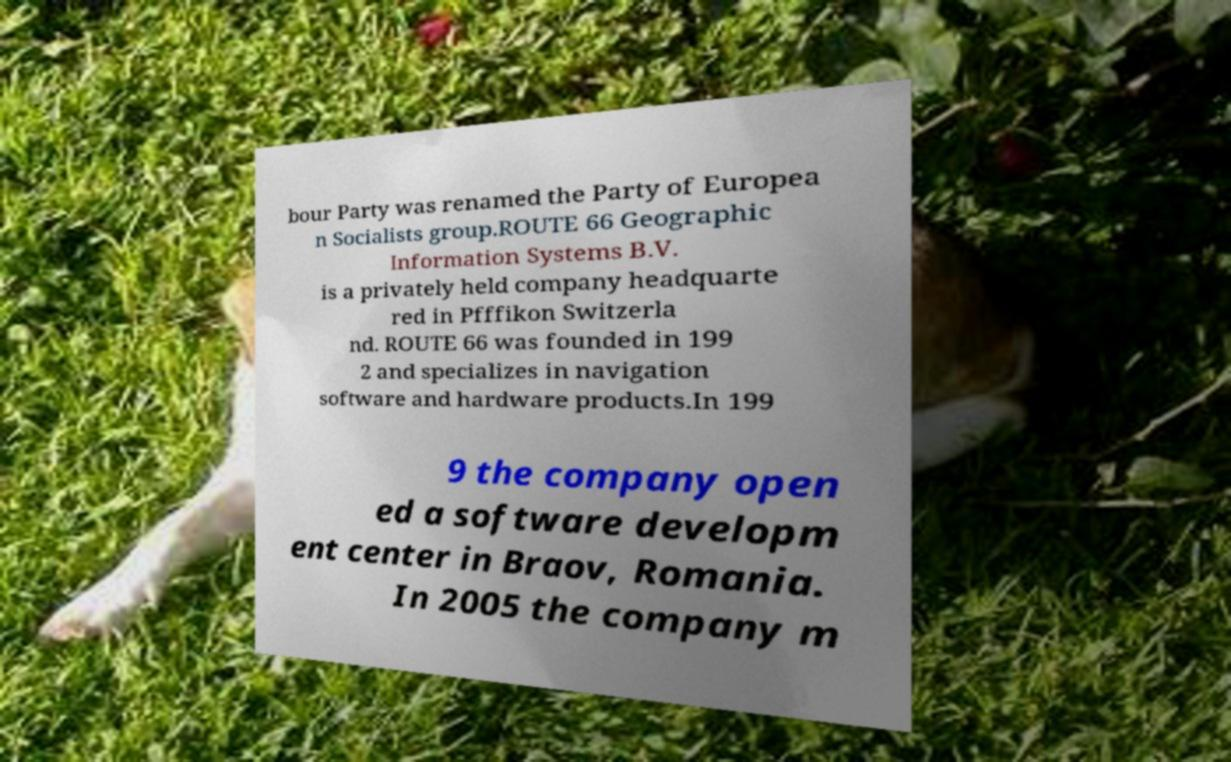Can you accurately transcribe the text from the provided image for me? bour Party was renamed the Party of Europea n Socialists group.ROUTE 66 Geographic Information Systems B.V. is a privately held company headquarte red in Pfffikon Switzerla nd. ROUTE 66 was founded in 199 2 and specializes in navigation software and hardware products.In 199 9 the company open ed a software developm ent center in Braov, Romania. In 2005 the company m 